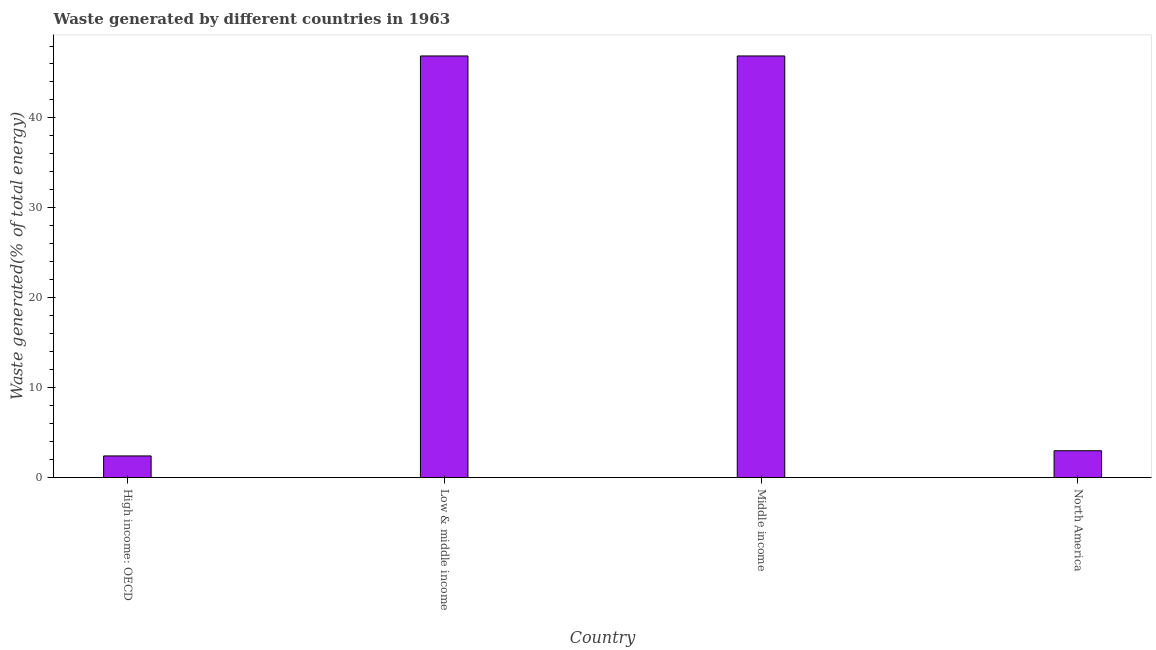What is the title of the graph?
Provide a short and direct response. Waste generated by different countries in 1963. What is the label or title of the X-axis?
Offer a very short reply. Country. What is the label or title of the Y-axis?
Provide a short and direct response. Waste generated(% of total energy). What is the amount of waste generated in North America?
Your response must be concise. 2.99. Across all countries, what is the maximum amount of waste generated?
Offer a very short reply. 46.89. Across all countries, what is the minimum amount of waste generated?
Keep it short and to the point. 2.41. In which country was the amount of waste generated minimum?
Your answer should be compact. High income: OECD. What is the sum of the amount of waste generated?
Ensure brevity in your answer.  99.19. What is the difference between the amount of waste generated in High income: OECD and Low & middle income?
Offer a very short reply. -44.48. What is the average amount of waste generated per country?
Provide a short and direct response. 24.8. What is the median amount of waste generated?
Provide a succinct answer. 24.94. In how many countries, is the amount of waste generated greater than 34 %?
Your answer should be very brief. 2. What is the ratio of the amount of waste generated in Low & middle income to that in North America?
Keep it short and to the point. 15.69. Is the difference between the amount of waste generated in Low & middle income and Middle income greater than the difference between any two countries?
Provide a short and direct response. No. What is the difference between the highest and the lowest amount of waste generated?
Provide a short and direct response. 44.48. In how many countries, is the amount of waste generated greater than the average amount of waste generated taken over all countries?
Your response must be concise. 2. How many bars are there?
Offer a very short reply. 4. How many countries are there in the graph?
Your response must be concise. 4. What is the difference between two consecutive major ticks on the Y-axis?
Your response must be concise. 10. What is the Waste generated(% of total energy) in High income: OECD?
Ensure brevity in your answer.  2.41. What is the Waste generated(% of total energy) of Low & middle income?
Offer a terse response. 46.89. What is the Waste generated(% of total energy) of Middle income?
Give a very brief answer. 46.89. What is the Waste generated(% of total energy) of North America?
Offer a terse response. 2.99. What is the difference between the Waste generated(% of total energy) in High income: OECD and Low & middle income?
Your answer should be compact. -44.48. What is the difference between the Waste generated(% of total energy) in High income: OECD and Middle income?
Your answer should be compact. -44.48. What is the difference between the Waste generated(% of total energy) in High income: OECD and North America?
Provide a short and direct response. -0.58. What is the difference between the Waste generated(% of total energy) in Low & middle income and North America?
Ensure brevity in your answer.  43.9. What is the difference between the Waste generated(% of total energy) in Middle income and North America?
Ensure brevity in your answer.  43.9. What is the ratio of the Waste generated(% of total energy) in High income: OECD to that in Low & middle income?
Offer a very short reply. 0.05. What is the ratio of the Waste generated(% of total energy) in High income: OECD to that in Middle income?
Your response must be concise. 0.05. What is the ratio of the Waste generated(% of total energy) in High income: OECD to that in North America?
Your response must be concise. 0.81. What is the ratio of the Waste generated(% of total energy) in Low & middle income to that in North America?
Offer a terse response. 15.69. What is the ratio of the Waste generated(% of total energy) in Middle income to that in North America?
Provide a succinct answer. 15.69. 